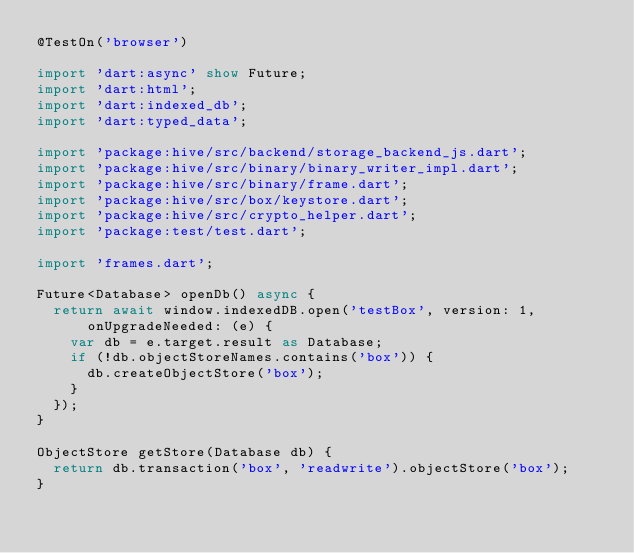Convert code to text. <code><loc_0><loc_0><loc_500><loc_500><_Dart_>@TestOn('browser')

import 'dart:async' show Future;
import 'dart:html';
import 'dart:indexed_db';
import 'dart:typed_data';

import 'package:hive/src/backend/storage_backend_js.dart';
import 'package:hive/src/binary/binary_writer_impl.dart';
import 'package:hive/src/binary/frame.dart';
import 'package:hive/src/box/keystore.dart';
import 'package:hive/src/crypto_helper.dart';
import 'package:test/test.dart';

import 'frames.dart';

Future<Database> openDb() async {
  return await window.indexedDB.open('testBox', version: 1,
      onUpgradeNeeded: (e) {
    var db = e.target.result as Database;
    if (!db.objectStoreNames.contains('box')) {
      db.createObjectStore('box');
    }
  });
}

ObjectStore getStore(Database db) {
  return db.transaction('box', 'readwrite').objectStore('box');
}
</code> 